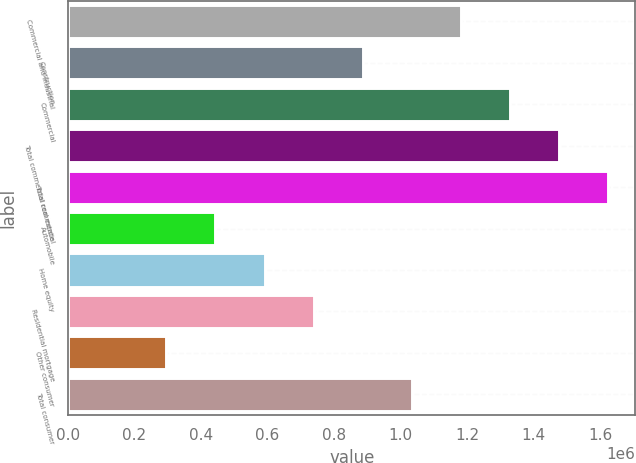Convert chart. <chart><loc_0><loc_0><loc_500><loc_500><bar_chart><fcel>Commercial and industrial<fcel>Construction<fcel>Commercial<fcel>Total commercial real estate<fcel>Total commercial<fcel>Automobile<fcel>Home equity<fcel>Residential mortgage<fcel>Other consumer<fcel>Total consumer<nl><fcel>1.18127e+06<fcel>885954<fcel>1.32893e+06<fcel>1.47659e+06<fcel>1.62425e+06<fcel>442979<fcel>590637<fcel>738295<fcel>295320<fcel>1.03361e+06<nl></chart> 